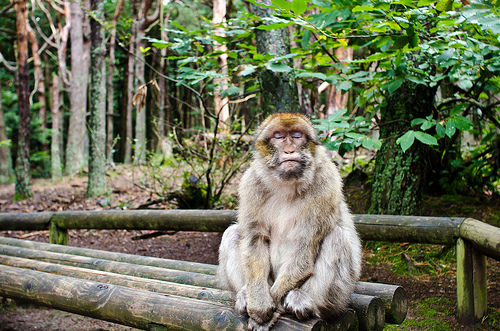<image>
Is the monkey on the bench? Yes. Looking at the image, I can see the monkey is positioned on top of the bench, with the bench providing support. Is there a wood under the monkey? Yes. The wood is positioned underneath the monkey, with the monkey above it in the vertical space. 